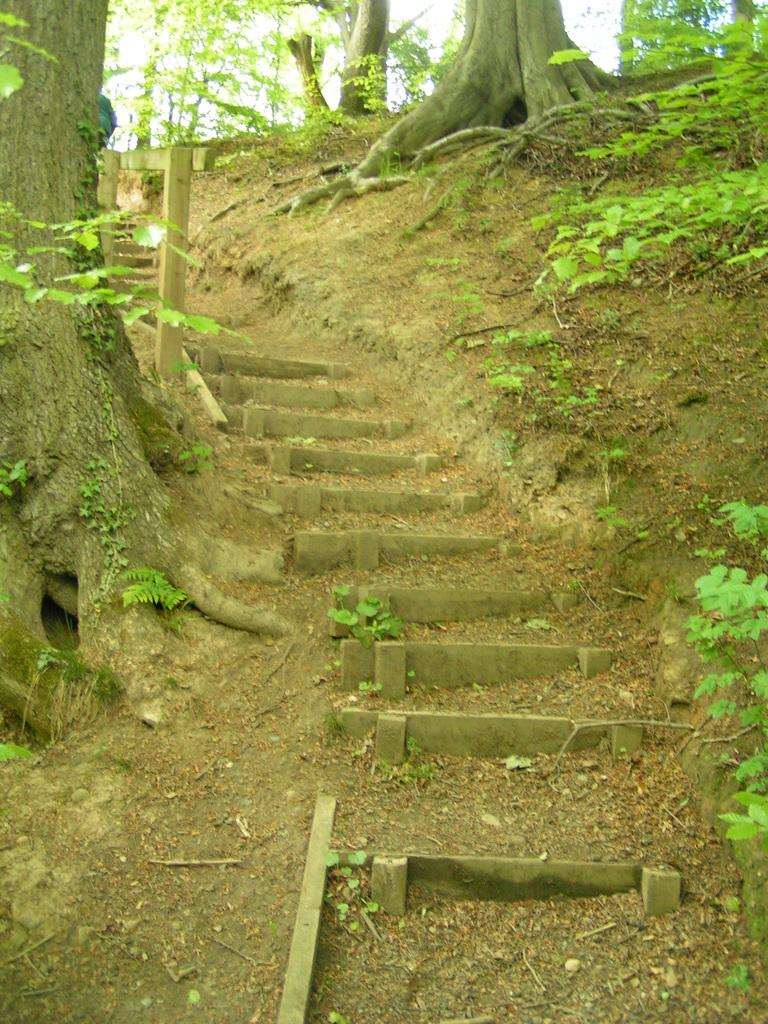What type of vegetation can be seen in the image? There are trees and plants in the image. What architectural feature is present in the image? There is a staircase in the image. What is the title of the book that the person is reading in the image? There is no person or book present in the image, so it is not possible to determine the title of a book. 